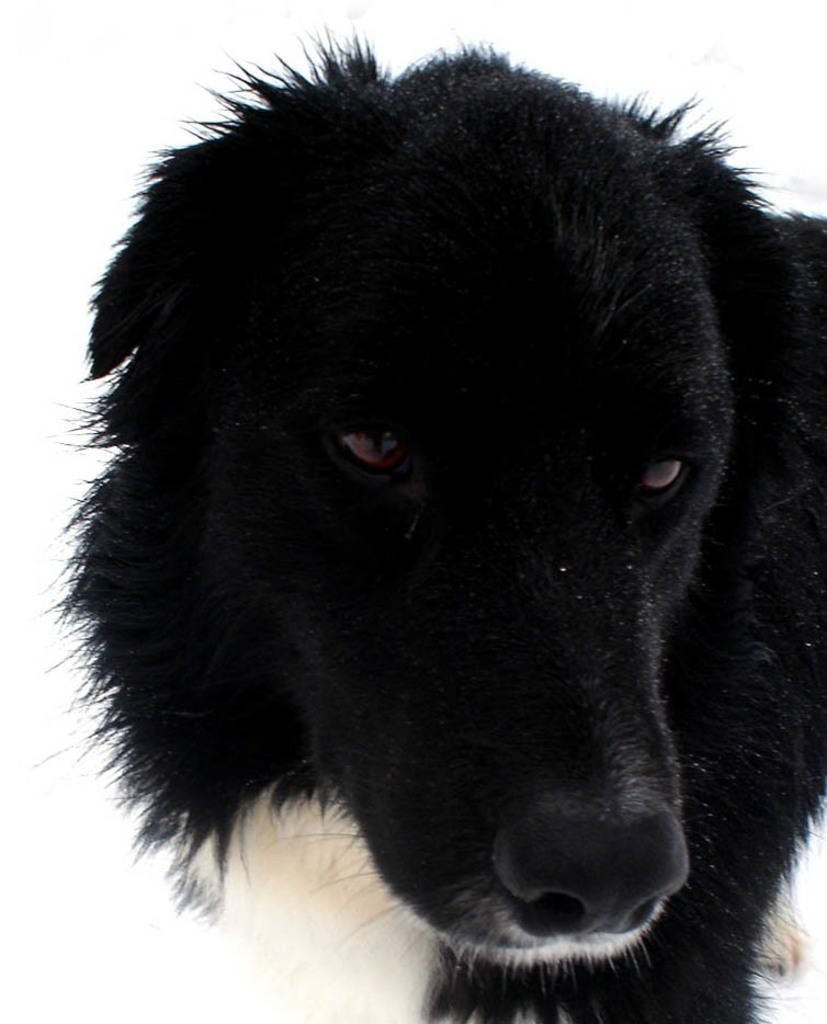What type of animal is in the image? There is a black color dog in the image. What color is the dog? The dog is black. What is the background color in the image? The background is white. What type of cloth is draped over the field in the image? There is no cloth or field present in the image; it features a black color dog with a white background. 